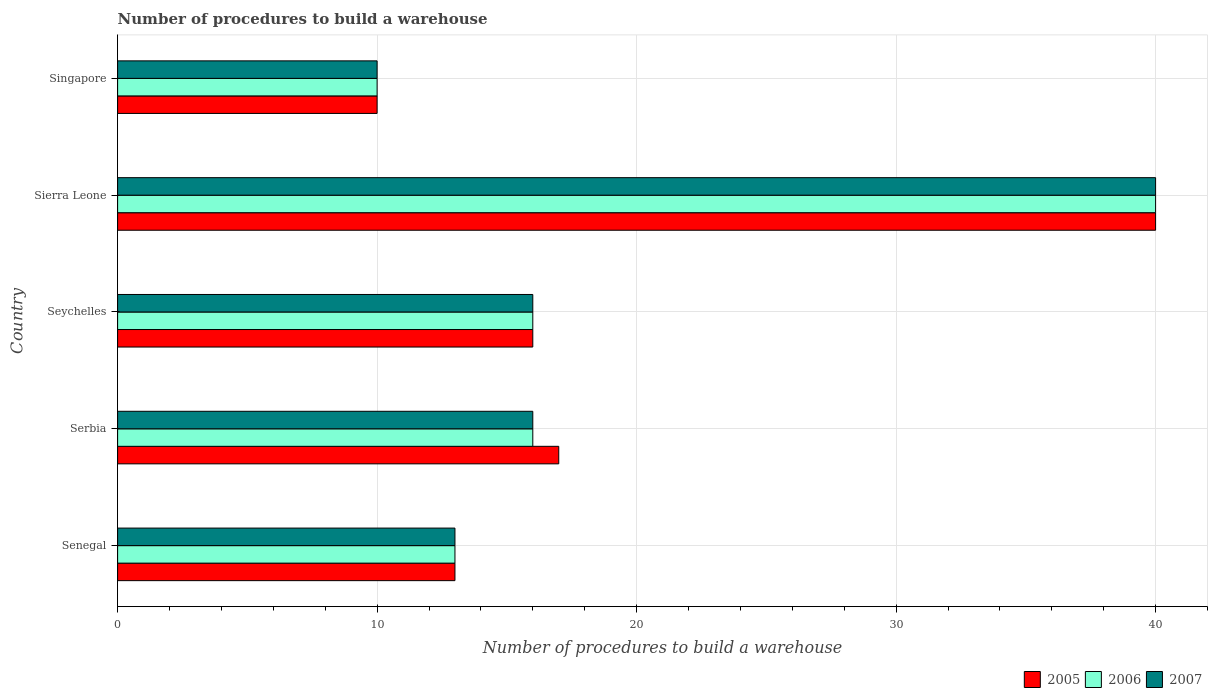How many different coloured bars are there?
Your response must be concise. 3. How many groups of bars are there?
Your answer should be compact. 5. How many bars are there on the 2nd tick from the top?
Ensure brevity in your answer.  3. How many bars are there on the 5th tick from the bottom?
Offer a terse response. 3. What is the label of the 5th group of bars from the top?
Provide a short and direct response. Senegal. Across all countries, what is the maximum number of procedures to build a warehouse in in 2005?
Your answer should be very brief. 40. Across all countries, what is the minimum number of procedures to build a warehouse in in 2007?
Make the answer very short. 10. In which country was the number of procedures to build a warehouse in in 2005 maximum?
Your response must be concise. Sierra Leone. In which country was the number of procedures to build a warehouse in in 2005 minimum?
Provide a short and direct response. Singapore. What is the total number of procedures to build a warehouse in in 2007 in the graph?
Provide a succinct answer. 95. What is the difference between the number of procedures to build a warehouse in in 2006 in Serbia and that in Sierra Leone?
Your response must be concise. -24. What is the difference between the number of procedures to build a warehouse in in 2006 and number of procedures to build a warehouse in in 2007 in Seychelles?
Offer a terse response. 0. What is the ratio of the number of procedures to build a warehouse in in 2006 in Senegal to that in Sierra Leone?
Your answer should be very brief. 0.33. Is the difference between the number of procedures to build a warehouse in in 2006 in Serbia and Singapore greater than the difference between the number of procedures to build a warehouse in in 2007 in Serbia and Singapore?
Your answer should be compact. No. What is the difference between the highest and the second highest number of procedures to build a warehouse in in 2005?
Give a very brief answer. 23. In how many countries, is the number of procedures to build a warehouse in in 2006 greater than the average number of procedures to build a warehouse in in 2006 taken over all countries?
Your response must be concise. 1. What does the 2nd bar from the top in Serbia represents?
Make the answer very short. 2006. What does the 1st bar from the bottom in Singapore represents?
Offer a terse response. 2005. How many bars are there?
Your answer should be compact. 15. Does the graph contain any zero values?
Your response must be concise. No. Does the graph contain grids?
Ensure brevity in your answer.  Yes. What is the title of the graph?
Your answer should be compact. Number of procedures to build a warehouse. What is the label or title of the X-axis?
Keep it short and to the point. Number of procedures to build a warehouse. What is the label or title of the Y-axis?
Offer a terse response. Country. What is the Number of procedures to build a warehouse in 2006 in Serbia?
Make the answer very short. 16. What is the Number of procedures to build a warehouse of 2007 in Serbia?
Your response must be concise. 16. What is the Number of procedures to build a warehouse of 2006 in Seychelles?
Make the answer very short. 16. What is the Number of procedures to build a warehouse of 2007 in Seychelles?
Offer a very short reply. 16. What is the Number of procedures to build a warehouse of 2005 in Singapore?
Make the answer very short. 10. What is the Number of procedures to build a warehouse of 2006 in Singapore?
Your response must be concise. 10. What is the Number of procedures to build a warehouse of 2007 in Singapore?
Make the answer very short. 10. Across all countries, what is the maximum Number of procedures to build a warehouse of 2006?
Your answer should be compact. 40. Across all countries, what is the maximum Number of procedures to build a warehouse in 2007?
Your answer should be compact. 40. Across all countries, what is the minimum Number of procedures to build a warehouse of 2005?
Your answer should be very brief. 10. Across all countries, what is the minimum Number of procedures to build a warehouse of 2007?
Your answer should be compact. 10. What is the total Number of procedures to build a warehouse of 2005 in the graph?
Make the answer very short. 96. What is the total Number of procedures to build a warehouse in 2007 in the graph?
Your response must be concise. 95. What is the difference between the Number of procedures to build a warehouse in 2005 in Senegal and that in Serbia?
Offer a terse response. -4. What is the difference between the Number of procedures to build a warehouse in 2007 in Senegal and that in Serbia?
Give a very brief answer. -3. What is the difference between the Number of procedures to build a warehouse of 2007 in Senegal and that in Seychelles?
Ensure brevity in your answer.  -3. What is the difference between the Number of procedures to build a warehouse in 2005 in Serbia and that in Seychelles?
Your answer should be very brief. 1. What is the difference between the Number of procedures to build a warehouse of 2005 in Serbia and that in Sierra Leone?
Keep it short and to the point. -23. What is the difference between the Number of procedures to build a warehouse of 2005 in Serbia and that in Singapore?
Keep it short and to the point. 7. What is the difference between the Number of procedures to build a warehouse of 2006 in Seychelles and that in Sierra Leone?
Your answer should be very brief. -24. What is the difference between the Number of procedures to build a warehouse in 2007 in Seychelles and that in Sierra Leone?
Your answer should be compact. -24. What is the difference between the Number of procedures to build a warehouse of 2006 in Seychelles and that in Singapore?
Provide a short and direct response. 6. What is the difference between the Number of procedures to build a warehouse of 2005 in Sierra Leone and that in Singapore?
Make the answer very short. 30. What is the difference between the Number of procedures to build a warehouse of 2006 in Sierra Leone and that in Singapore?
Offer a terse response. 30. What is the difference between the Number of procedures to build a warehouse of 2006 in Senegal and the Number of procedures to build a warehouse of 2007 in Serbia?
Your response must be concise. -3. What is the difference between the Number of procedures to build a warehouse in 2005 in Senegal and the Number of procedures to build a warehouse in 2006 in Seychelles?
Ensure brevity in your answer.  -3. What is the difference between the Number of procedures to build a warehouse in 2006 in Senegal and the Number of procedures to build a warehouse in 2007 in Seychelles?
Ensure brevity in your answer.  -3. What is the difference between the Number of procedures to build a warehouse of 2005 in Senegal and the Number of procedures to build a warehouse of 2007 in Sierra Leone?
Ensure brevity in your answer.  -27. What is the difference between the Number of procedures to build a warehouse of 2006 in Senegal and the Number of procedures to build a warehouse of 2007 in Sierra Leone?
Keep it short and to the point. -27. What is the difference between the Number of procedures to build a warehouse of 2005 in Senegal and the Number of procedures to build a warehouse of 2006 in Singapore?
Your response must be concise. 3. What is the difference between the Number of procedures to build a warehouse of 2006 in Senegal and the Number of procedures to build a warehouse of 2007 in Singapore?
Your answer should be very brief. 3. What is the difference between the Number of procedures to build a warehouse in 2005 in Serbia and the Number of procedures to build a warehouse in 2006 in Seychelles?
Ensure brevity in your answer.  1. What is the difference between the Number of procedures to build a warehouse in 2005 in Serbia and the Number of procedures to build a warehouse in 2007 in Sierra Leone?
Your answer should be very brief. -23. What is the difference between the Number of procedures to build a warehouse in 2006 in Serbia and the Number of procedures to build a warehouse in 2007 in Sierra Leone?
Your answer should be very brief. -24. What is the difference between the Number of procedures to build a warehouse of 2005 in Serbia and the Number of procedures to build a warehouse of 2007 in Singapore?
Give a very brief answer. 7. What is the difference between the Number of procedures to build a warehouse in 2006 in Seychelles and the Number of procedures to build a warehouse in 2007 in Singapore?
Your response must be concise. 6. What is the difference between the Number of procedures to build a warehouse of 2005 in Sierra Leone and the Number of procedures to build a warehouse of 2006 in Singapore?
Your answer should be compact. 30. What is the difference between the Number of procedures to build a warehouse of 2005 in Sierra Leone and the Number of procedures to build a warehouse of 2007 in Singapore?
Your response must be concise. 30. What is the average Number of procedures to build a warehouse of 2005 per country?
Your answer should be compact. 19.2. What is the average Number of procedures to build a warehouse of 2006 per country?
Give a very brief answer. 19. What is the difference between the Number of procedures to build a warehouse of 2005 and Number of procedures to build a warehouse of 2006 in Senegal?
Your answer should be very brief. 0. What is the difference between the Number of procedures to build a warehouse of 2006 and Number of procedures to build a warehouse of 2007 in Senegal?
Keep it short and to the point. 0. What is the difference between the Number of procedures to build a warehouse in 2005 and Number of procedures to build a warehouse in 2006 in Serbia?
Make the answer very short. 1. What is the difference between the Number of procedures to build a warehouse of 2006 and Number of procedures to build a warehouse of 2007 in Serbia?
Provide a short and direct response. 0. What is the difference between the Number of procedures to build a warehouse in 2005 and Number of procedures to build a warehouse in 2007 in Seychelles?
Your response must be concise. 0. What is the difference between the Number of procedures to build a warehouse of 2005 and Number of procedures to build a warehouse of 2006 in Sierra Leone?
Keep it short and to the point. 0. What is the difference between the Number of procedures to build a warehouse in 2006 and Number of procedures to build a warehouse in 2007 in Sierra Leone?
Your answer should be compact. 0. What is the difference between the Number of procedures to build a warehouse in 2005 and Number of procedures to build a warehouse in 2007 in Singapore?
Provide a succinct answer. 0. What is the difference between the Number of procedures to build a warehouse in 2006 and Number of procedures to build a warehouse in 2007 in Singapore?
Your answer should be very brief. 0. What is the ratio of the Number of procedures to build a warehouse in 2005 in Senegal to that in Serbia?
Make the answer very short. 0.76. What is the ratio of the Number of procedures to build a warehouse of 2006 in Senegal to that in Serbia?
Provide a succinct answer. 0.81. What is the ratio of the Number of procedures to build a warehouse of 2007 in Senegal to that in Serbia?
Provide a succinct answer. 0.81. What is the ratio of the Number of procedures to build a warehouse of 2005 in Senegal to that in Seychelles?
Provide a short and direct response. 0.81. What is the ratio of the Number of procedures to build a warehouse of 2006 in Senegal to that in Seychelles?
Provide a succinct answer. 0.81. What is the ratio of the Number of procedures to build a warehouse in 2007 in Senegal to that in Seychelles?
Your answer should be very brief. 0.81. What is the ratio of the Number of procedures to build a warehouse in 2005 in Senegal to that in Sierra Leone?
Keep it short and to the point. 0.33. What is the ratio of the Number of procedures to build a warehouse in 2006 in Senegal to that in Sierra Leone?
Your answer should be very brief. 0.33. What is the ratio of the Number of procedures to build a warehouse of 2007 in Senegal to that in Sierra Leone?
Your answer should be very brief. 0.33. What is the ratio of the Number of procedures to build a warehouse in 2005 in Senegal to that in Singapore?
Offer a very short reply. 1.3. What is the ratio of the Number of procedures to build a warehouse of 2006 in Senegal to that in Singapore?
Your response must be concise. 1.3. What is the ratio of the Number of procedures to build a warehouse of 2007 in Serbia to that in Seychelles?
Offer a very short reply. 1. What is the ratio of the Number of procedures to build a warehouse in 2005 in Serbia to that in Sierra Leone?
Your answer should be compact. 0.42. What is the ratio of the Number of procedures to build a warehouse of 2006 in Serbia to that in Sierra Leone?
Give a very brief answer. 0.4. What is the ratio of the Number of procedures to build a warehouse of 2007 in Serbia to that in Sierra Leone?
Your answer should be compact. 0.4. What is the ratio of the Number of procedures to build a warehouse of 2006 in Serbia to that in Singapore?
Offer a very short reply. 1.6. What is the ratio of the Number of procedures to build a warehouse of 2005 in Seychelles to that in Sierra Leone?
Ensure brevity in your answer.  0.4. What is the ratio of the Number of procedures to build a warehouse of 2006 in Seychelles to that in Sierra Leone?
Keep it short and to the point. 0.4. What is the ratio of the Number of procedures to build a warehouse of 2005 in Seychelles to that in Singapore?
Provide a succinct answer. 1.6. What is the ratio of the Number of procedures to build a warehouse of 2005 in Sierra Leone to that in Singapore?
Your answer should be compact. 4. What is the ratio of the Number of procedures to build a warehouse of 2006 in Sierra Leone to that in Singapore?
Provide a short and direct response. 4. What is the ratio of the Number of procedures to build a warehouse of 2007 in Sierra Leone to that in Singapore?
Give a very brief answer. 4. What is the difference between the highest and the second highest Number of procedures to build a warehouse in 2005?
Provide a succinct answer. 23. What is the difference between the highest and the second highest Number of procedures to build a warehouse of 2007?
Provide a succinct answer. 24. What is the difference between the highest and the lowest Number of procedures to build a warehouse of 2007?
Provide a short and direct response. 30. 